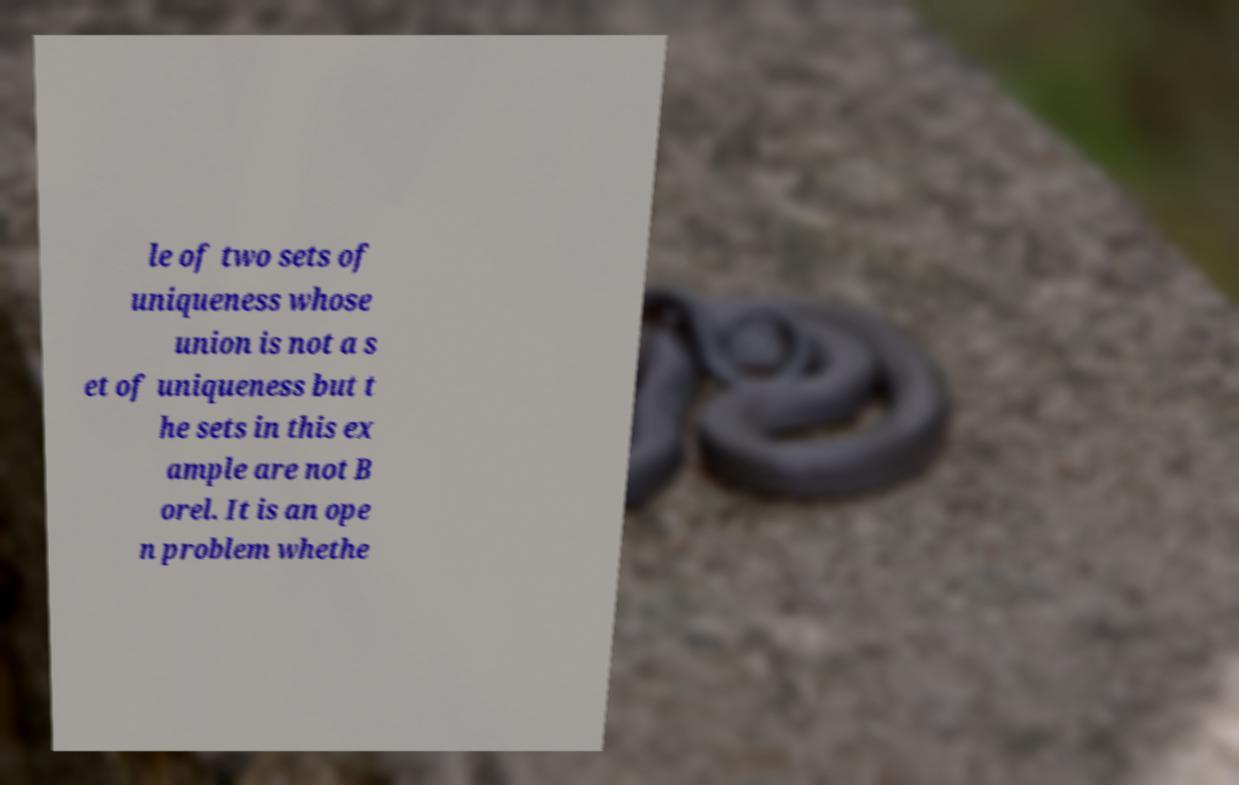Can you read and provide the text displayed in the image?This photo seems to have some interesting text. Can you extract and type it out for me? le of two sets of uniqueness whose union is not a s et of uniqueness but t he sets in this ex ample are not B orel. It is an ope n problem whethe 